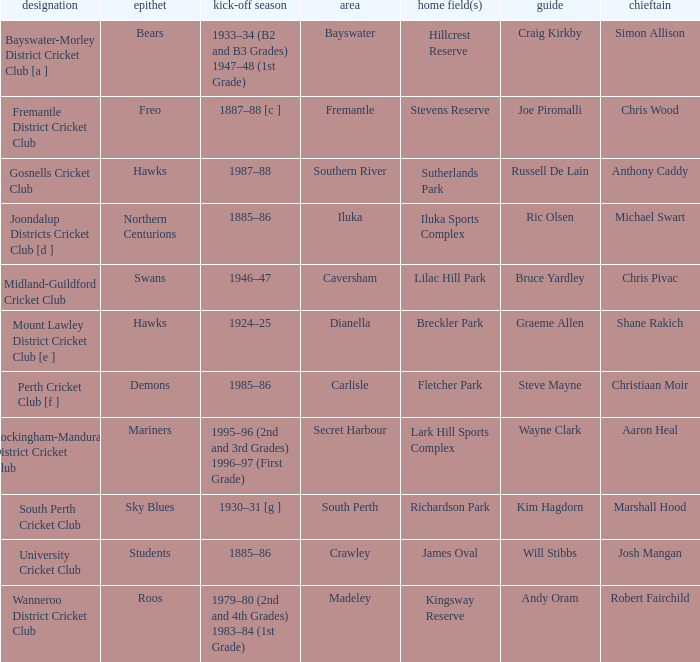What is the dates where Hillcrest Reserve is the home grounds? 1933–34 (B2 and B3 Grades) 1947–48 (1st Grade). 